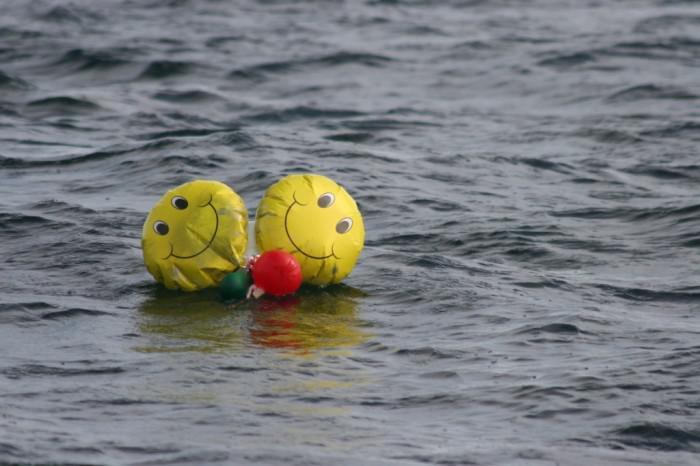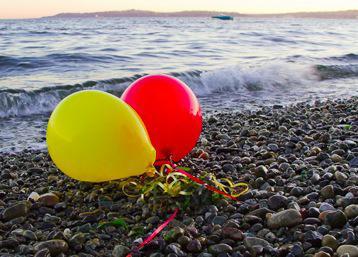The first image is the image on the left, the second image is the image on the right. Given the left and right images, does the statement "Only balloons with green-and-yellow color schemes are shown, and the image includes a balloon with a diamond shape on it." hold true? Answer yes or no. No. The first image is the image on the left, the second image is the image on the right. Considering the images on both sides, is "There is at least one green and yellow balloon in the image on the left." valid? Answer yes or no. No. 